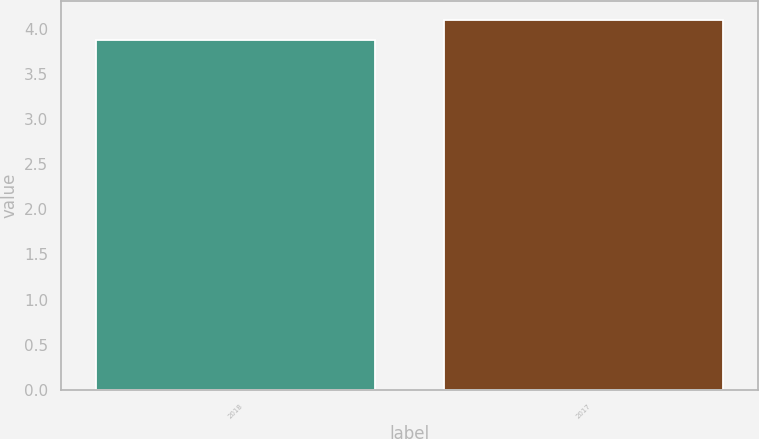Convert chart to OTSL. <chart><loc_0><loc_0><loc_500><loc_500><bar_chart><fcel>2018<fcel>2017<nl><fcel>3.87<fcel>4.1<nl></chart> 